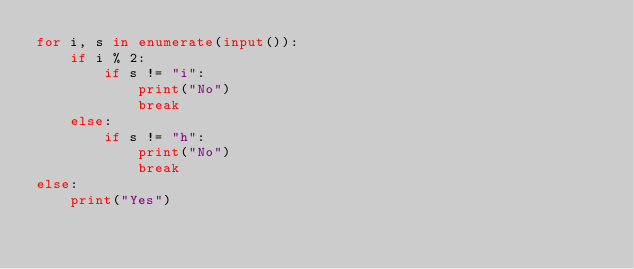<code> <loc_0><loc_0><loc_500><loc_500><_Python_>for i, s in enumerate(input()):
    if i % 2:
        if s != "i":
            print("No")
            break
    else:
        if s != "h":
            print("No")
            break
else:
    print("Yes")</code> 